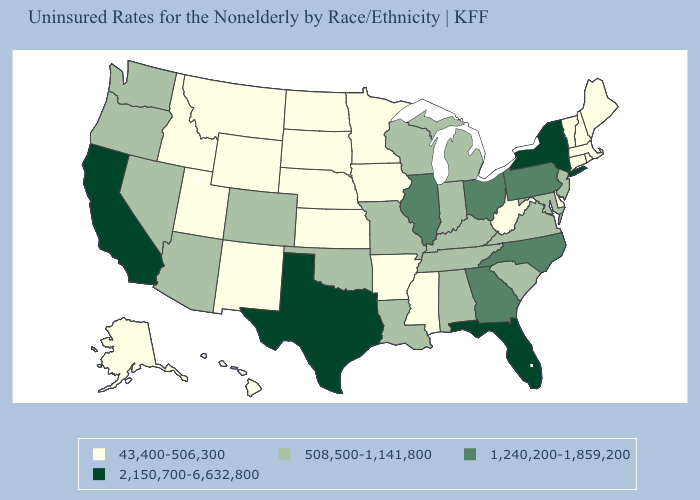What is the value of Nebraska?
Give a very brief answer. 43,400-506,300. Does New Hampshire have a higher value than Wyoming?
Give a very brief answer. No. What is the value of Nebraska?
Answer briefly. 43,400-506,300. What is the highest value in the USA?
Give a very brief answer. 2,150,700-6,632,800. Does Alabama have the same value as Tennessee?
Concise answer only. Yes. What is the value of Nevada?
Short answer required. 508,500-1,141,800. Does the map have missing data?
Give a very brief answer. No. What is the value of North Carolina?
Write a very short answer. 1,240,200-1,859,200. How many symbols are there in the legend?
Short answer required. 4. Name the states that have a value in the range 43,400-506,300?
Short answer required. Alaska, Arkansas, Connecticut, Delaware, Hawaii, Idaho, Iowa, Kansas, Maine, Massachusetts, Minnesota, Mississippi, Montana, Nebraska, New Hampshire, New Mexico, North Dakota, Rhode Island, South Dakota, Utah, Vermont, West Virginia, Wyoming. Name the states that have a value in the range 2,150,700-6,632,800?
Give a very brief answer. California, Florida, New York, Texas. How many symbols are there in the legend?
Keep it brief. 4. Which states hav the highest value in the Northeast?
Quick response, please. New York. What is the highest value in the USA?
Short answer required. 2,150,700-6,632,800. 